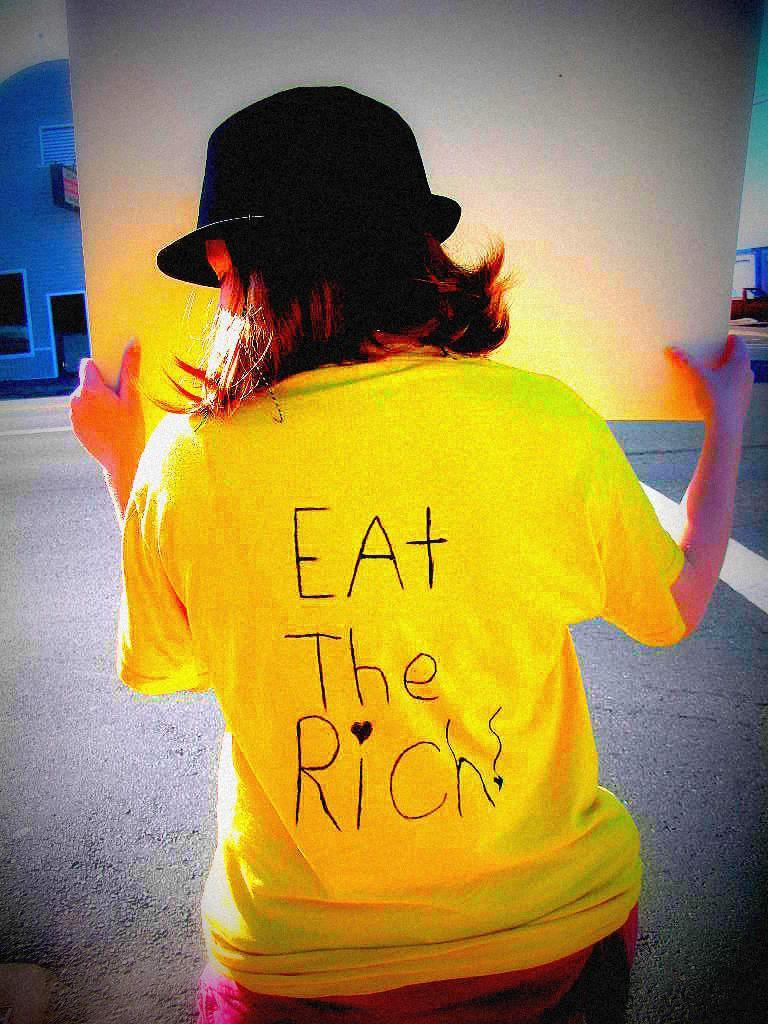Describe this image in one or two sentences. In this image I can see the person is holding the board and the person is wearing black color cap and yellow color dress. I can see the blue color building and few objects around. 